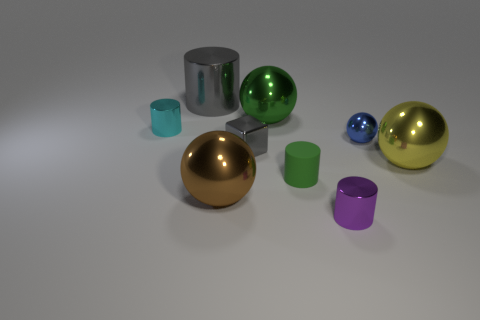If these objects were part of a physics experiment, what could they be used to demonstrate? If these objects were employed in a physics experiment, they could be used to demonstrate principles such as light reflection and refraction, material density, and the laws of motion. For example, the reflective surfaces are excellent for showing how light bounces off smooth, metallic materials, while their shapes and sizes could be used to examine how different forces impact motion and balance. 